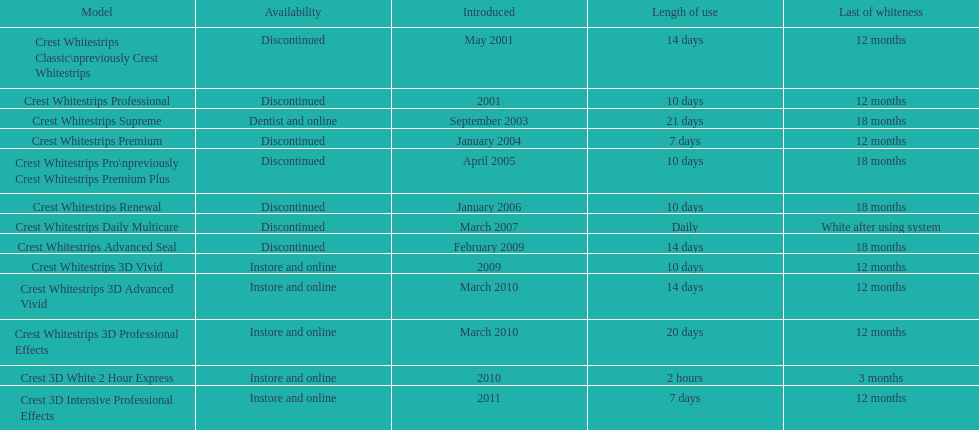For how many models is the required usage period under a week? 2. 